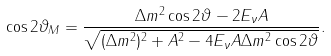<formula> <loc_0><loc_0><loc_500><loc_500>\cos 2 \vartheta _ { M } = \frac { \Delta m ^ { 2 } \cos 2 \vartheta - 2 E _ { \nu } A } { \sqrt { ( \Delta m ^ { 2 } ) ^ { 2 } + A ^ { 2 } - 4 E _ { \nu } A \Delta m ^ { 2 } \cos 2 \vartheta } } .</formula> 